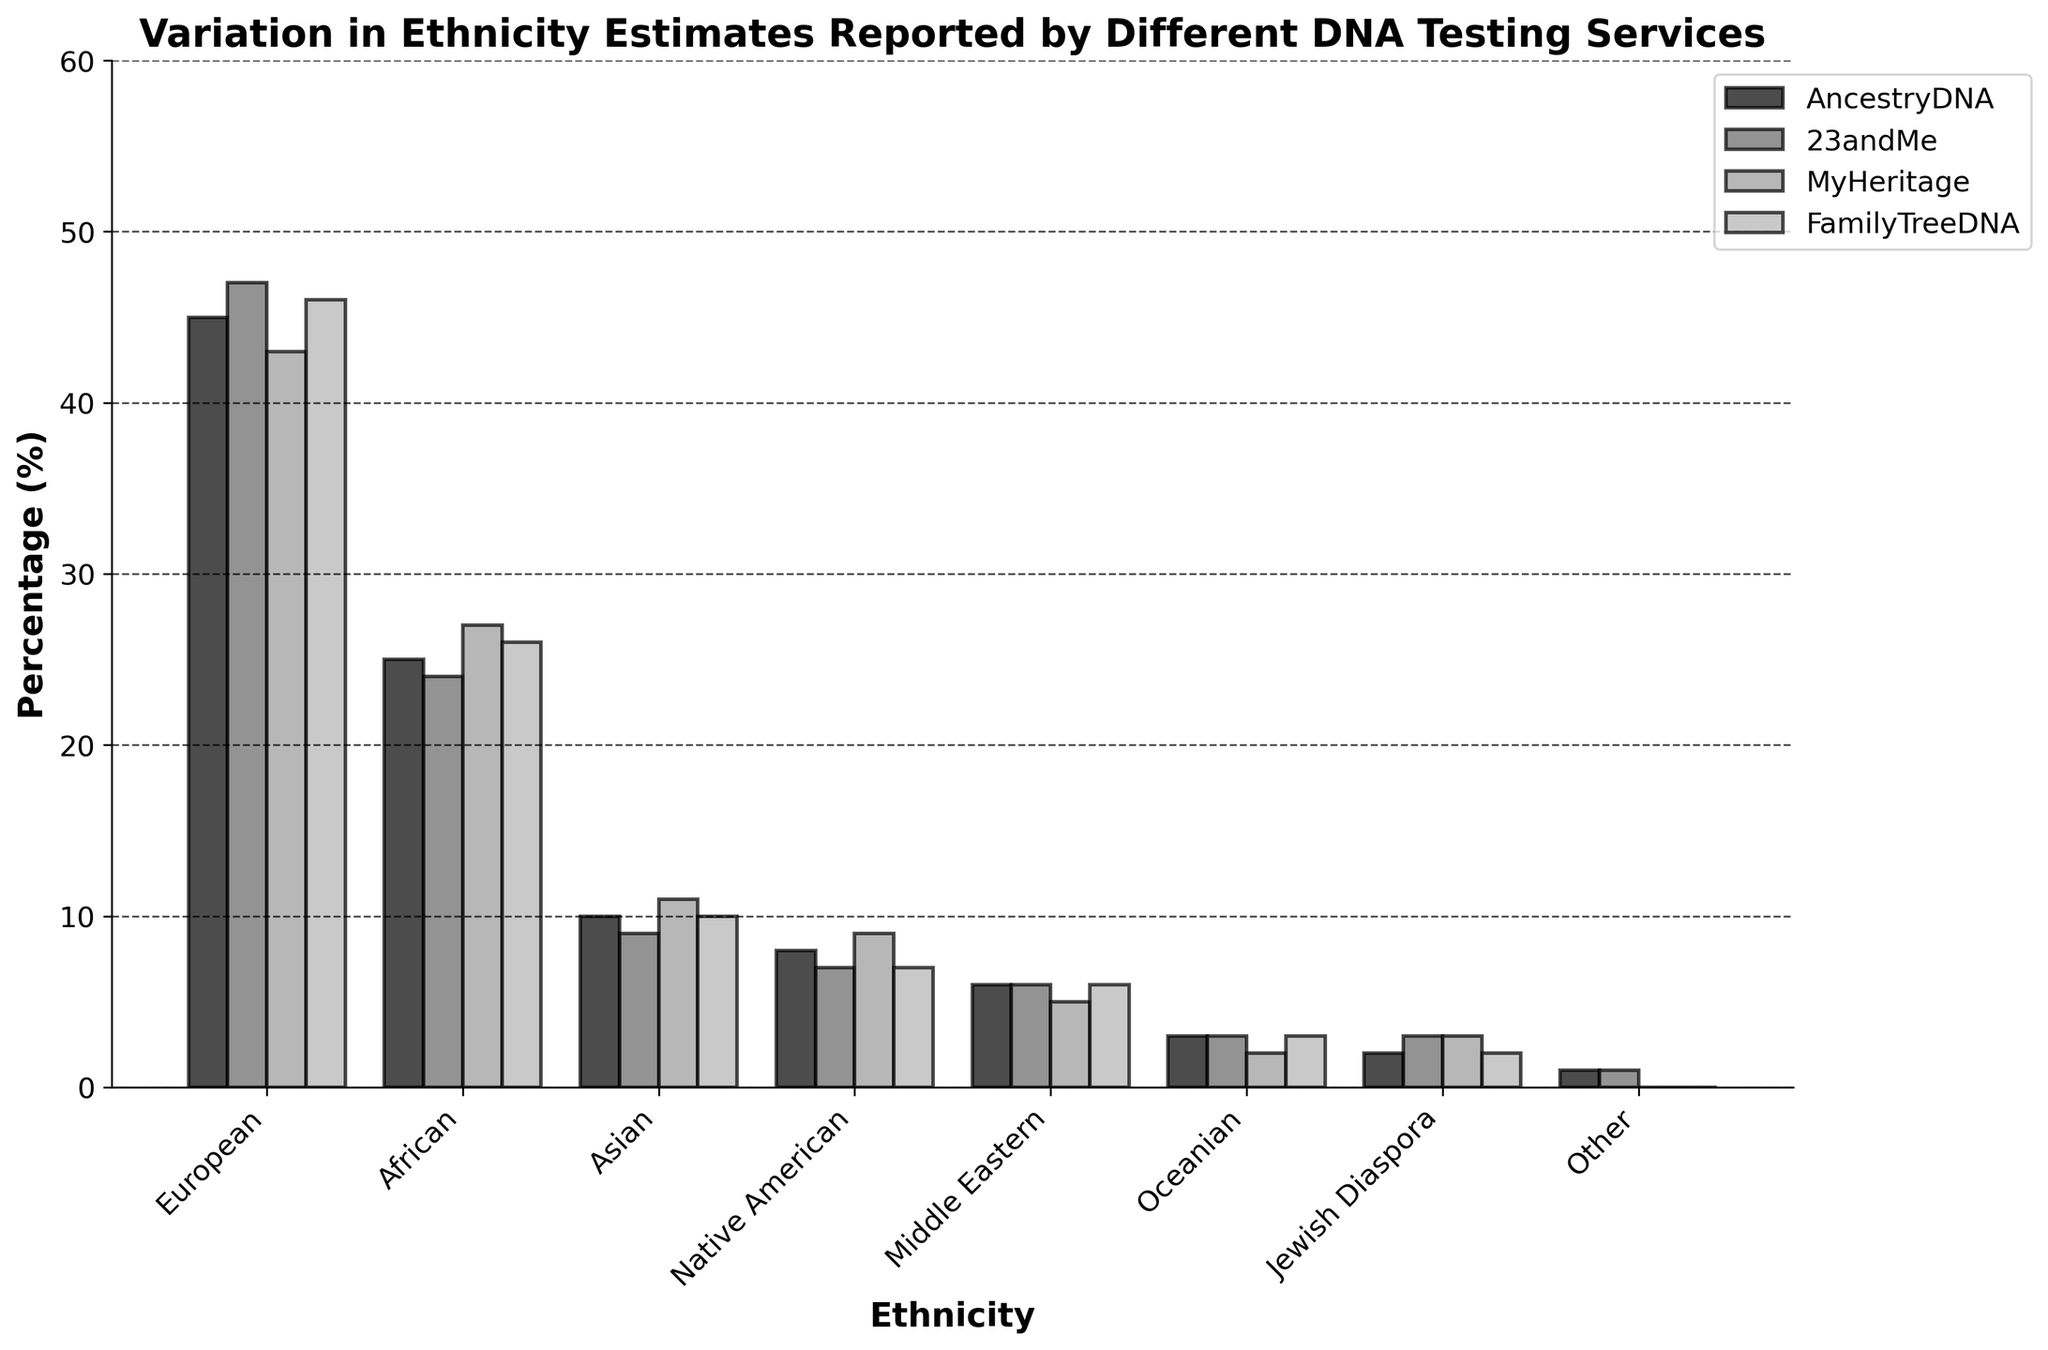What is the title of the figure? The title of the figure is displayed at the top and summarizes what the plot is about.
Answer: Variation in Ethnicity Estimates Reported by Different DNA Testing Services Which ethnicity has the highest percentage in AncestryDNA? For AncestryDNA, the tallest bar represents the highest percentage, which is for European ethnicity.
Answer: European How many ethnicities are represented in the figure? Count the number of bars (or labeled xticks) along the x-axis.
Answer: Eight What is the average percentage of the European ethnicity reported by all DNA testing services? Add the percentages for European from all four services (45 + 47 + 43 + 46) and then divide by 4.
Answer: 45.25% Which DNA testing service reported the highest percentage for the African ethnicity? Compare the heights of the bars for African ethnicity across the four services; the tallest bar is for MyHeritage.
Answer: MyHeritage Which ethnicity shows the least variation in percentage across different DNA testing services? Least variation means bars of almost the same height for one ethnicity over the services. Oceanian ethnicity has bars of 3, 3, 2, and 3, showing minimal variation.
Answer: Oceanian Between AncestryDNA and FamilyTreeDNA, which service reports a higher percentage for Middle Eastern ethnicity? Compare the heights of bars for Middle Eastern ethnicity specifically for AncestryDNA and FamilyTreeDNA. Both report 6%.
Answer: Both equal What is the total percentage reported by AncestryDNA for European and African ethnicities combined? Sum the percentages for European (45) and African (25) ethnicities reported by AncestryDNA.
Answer: 70% Which service shows a percentage for Jewish Diaspora that differs from AncestryDNA? Compare the Jewish Diaspora percentages across the services, noting which ones are different from AncestryDNA's 2%. 23andMe and MyHeritage both report 3% while FamilyTreeDNA is the same at 2%.
Answer: 23andMe, MyHeritage How much higher is the Asian percentage reported by MyHeritage compared to 23andMe? Subtract the Asian percentage reported by 23andMe (9%) from the percentage reported by MyHeritage (11%).
Answer: 2% 